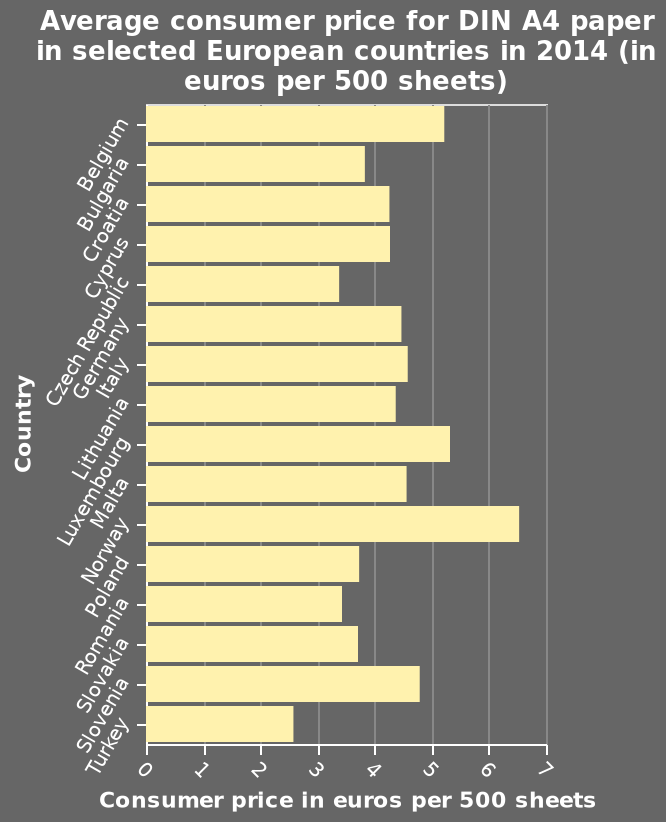<image>
How much cheaper is A4 paper in Turkey compared to Norway?  2.5 times less. 